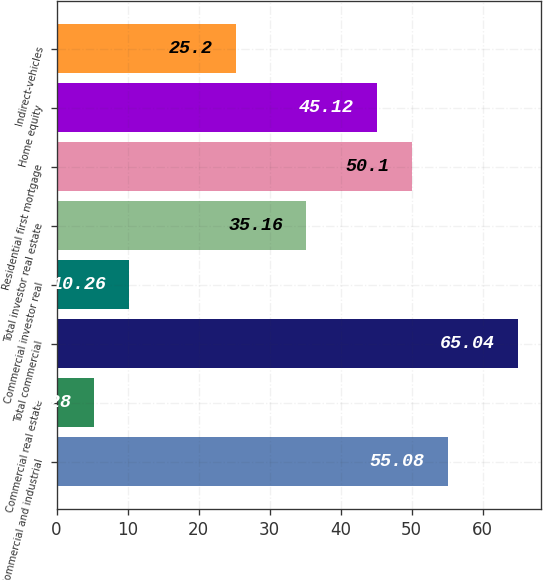Convert chart to OTSL. <chart><loc_0><loc_0><loc_500><loc_500><bar_chart><fcel>Commercial and industrial<fcel>Commercial real estate<fcel>Total commercial<fcel>Commercial investor real<fcel>Total investor real estate<fcel>Residential first mortgage<fcel>Home equity<fcel>Indirect-vehicles<nl><fcel>55.08<fcel>5.28<fcel>65.04<fcel>10.26<fcel>35.16<fcel>50.1<fcel>45.12<fcel>25.2<nl></chart> 